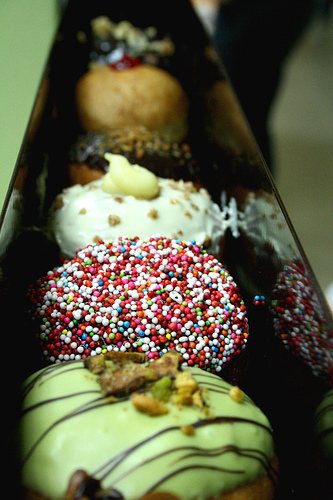Please provide the bounding box coordinate of the region this sentence describes: bottom desert. The request for a bounding box of a 'bottom desert' cannot be fulfilled as the image displayed is of doughnuts with various toppings in a box. There is no desert region depicted in the image. 